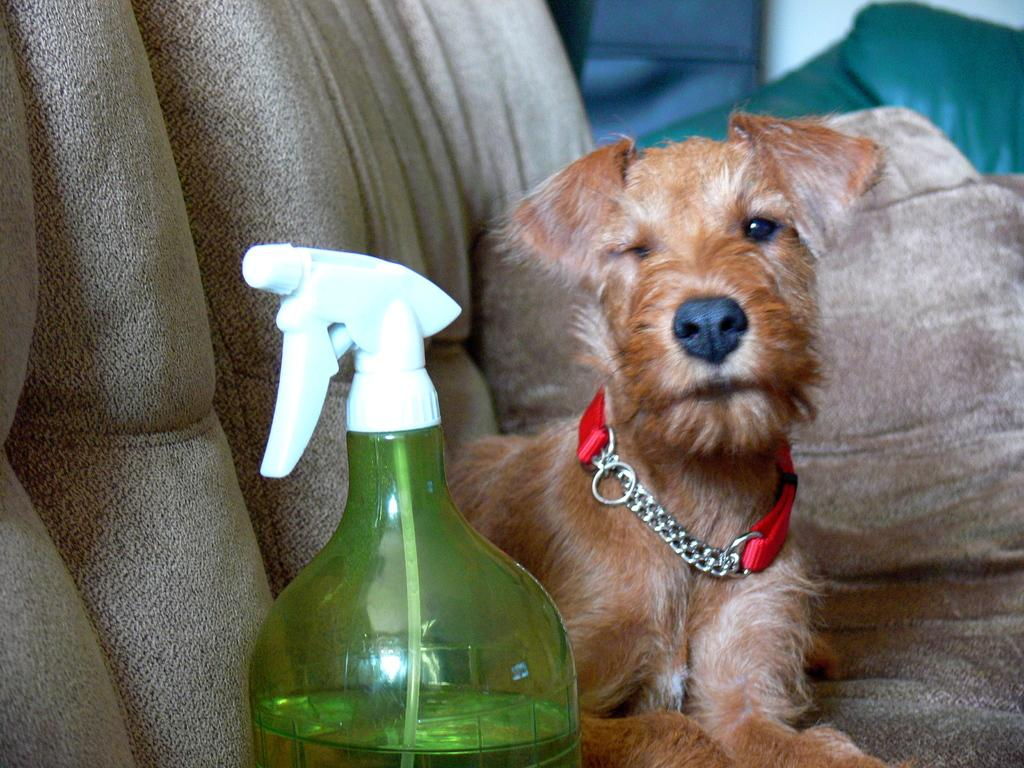What animal is on the sofa in the image? There is a dog on the sofa in the image. What object can be seen in the image besides the dog? There is a bottle and a pillow in the image. Is the baby playing in the quicksand in the image? There is no baby or quicksand present in the image. 